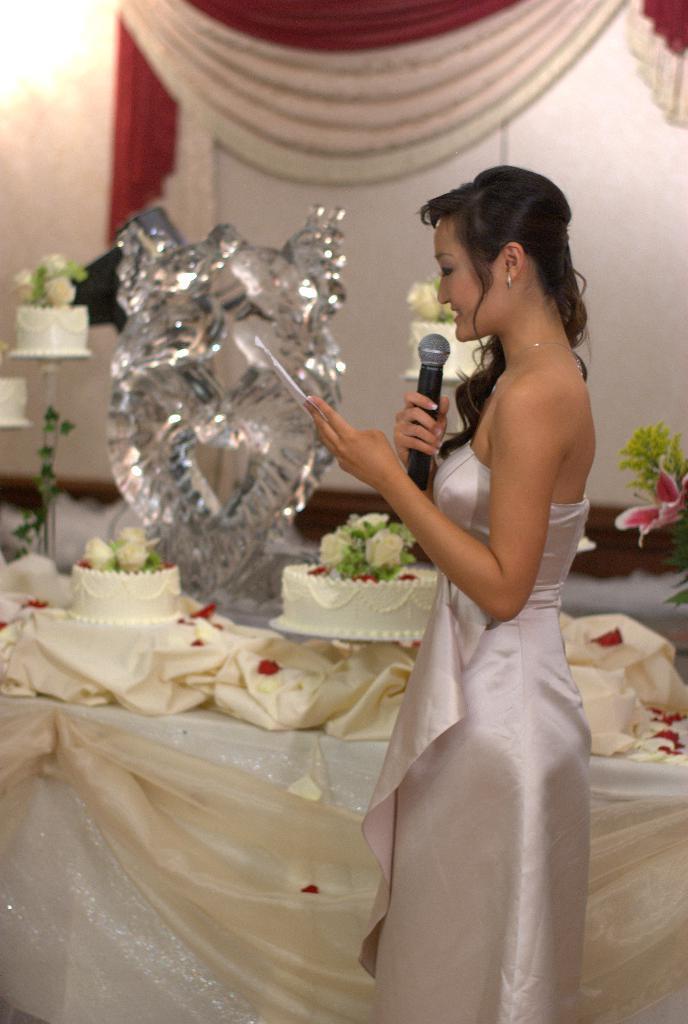In one or two sentences, can you explain what this image depicts? In this image we can see a lady. A lady is speaking into a microphone and holding some object in her hand. There are few cakes in the image. There is a lamp at the left top of the image. There is a curtain in the image. There is a bouquet in the image. There are tables in the image. 